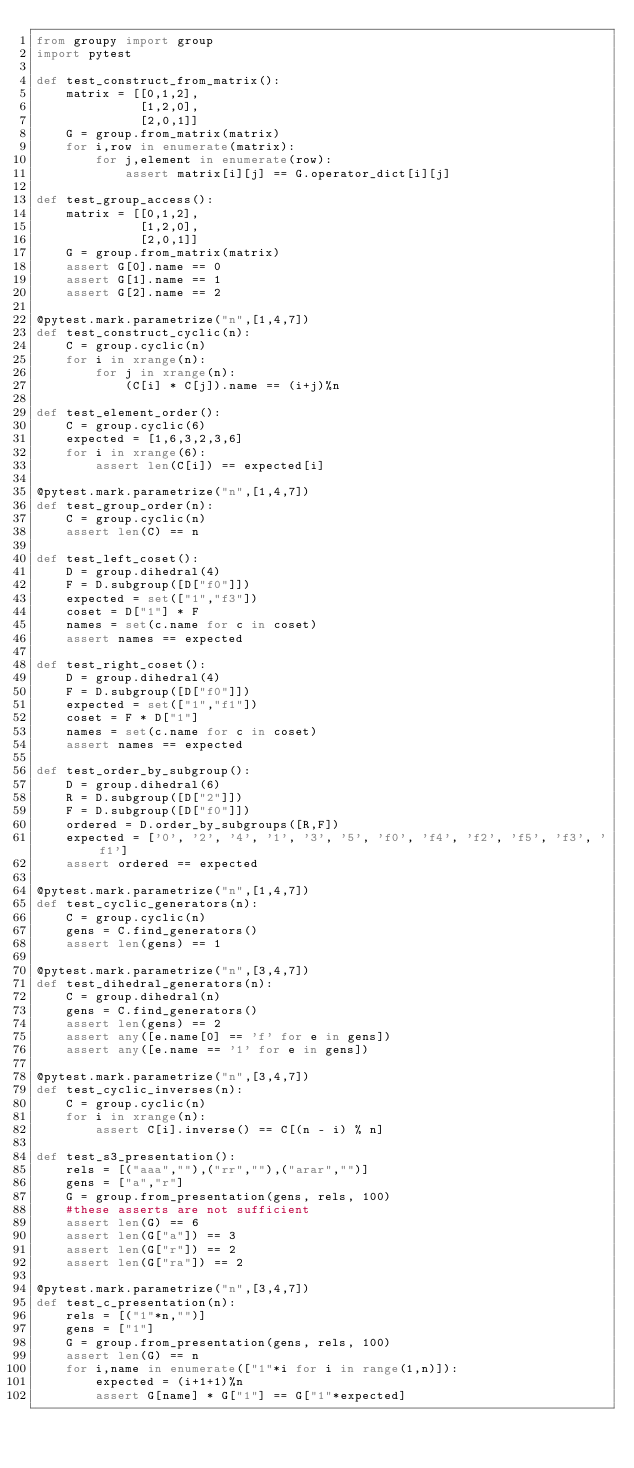Convert code to text. <code><loc_0><loc_0><loc_500><loc_500><_Python_>from groupy import group
import pytest

def test_construct_from_matrix():
    matrix = [[0,1,2],
              [1,2,0],
              [2,0,1]]
    G = group.from_matrix(matrix)
    for i,row in enumerate(matrix):
        for j,element in enumerate(row):
            assert matrix[i][j] == G.operator_dict[i][j]

def test_group_access():
    matrix = [[0,1,2],
              [1,2,0],
              [2,0,1]]
    G = group.from_matrix(matrix)
    assert G[0].name == 0
    assert G[1].name == 1
    assert G[2].name == 2

@pytest.mark.parametrize("n",[1,4,7])
def test_construct_cyclic(n):
    C = group.cyclic(n)
    for i in xrange(n):
        for j in xrange(n):
            (C[i] * C[j]).name == (i+j)%n

def test_element_order():
    C = group.cyclic(6)
    expected = [1,6,3,2,3,6]
    for i in xrange(6):
        assert len(C[i]) == expected[i]

@pytest.mark.parametrize("n",[1,4,7])
def test_group_order(n):
    C = group.cyclic(n)
    assert len(C) == n

def test_left_coset():
    D = group.dihedral(4)
    F = D.subgroup([D["f0"]])
    expected = set(["1","f3"])
    coset = D["1"] * F
    names = set(c.name for c in coset)
    assert names == expected

def test_right_coset():
    D = group.dihedral(4)
    F = D.subgroup([D["f0"]])
    expected = set(["1","f1"])
    coset = F * D["1"]
    names = set(c.name for c in coset)
    assert names == expected

def test_order_by_subgroup():
    D = group.dihedral(6)
    R = D.subgroup([D["2"]])
    F = D.subgroup([D["f0"]])
    ordered = D.order_by_subgroups([R,F])
    expected = ['0', '2', '4', '1', '3', '5', 'f0', 'f4', 'f2', 'f5', 'f3', 'f1']
    assert ordered == expected

@pytest.mark.parametrize("n",[1,4,7])
def test_cyclic_generators(n):
    C = group.cyclic(n)
    gens = C.find_generators()
    assert len(gens) == 1

@pytest.mark.parametrize("n",[3,4,7])
def test_dihedral_generators(n):
    C = group.dihedral(n)
    gens = C.find_generators()
    assert len(gens) == 2
    assert any([e.name[0] == 'f' for e in gens])
    assert any([e.name == '1' for e in gens])

@pytest.mark.parametrize("n",[3,4,7])
def test_cyclic_inverses(n):
    C = group.cyclic(n)
    for i in xrange(n):
        assert C[i].inverse() == C[(n - i) % n]

def test_s3_presentation():
    rels = [("aaa",""),("rr",""),("arar","")]
    gens = ["a","r"]
    G = group.from_presentation(gens, rels, 100)
    #these asserts are not sufficient
    assert len(G) == 6
    assert len(G["a"]) == 3
    assert len(G["r"]) == 2
    assert len(G["ra"]) == 2

@pytest.mark.parametrize("n",[3,4,7])
def test_c_presentation(n):
    rels = [("1"*n,"")]
    gens = ["1"]
    G = group.from_presentation(gens, rels, 100)
    assert len(G) == n
    for i,name in enumerate(["1"*i for i in range(1,n)]):
        expected = (i+1+1)%n
        assert G[name] * G["1"] == G["1"*expected]
</code> 